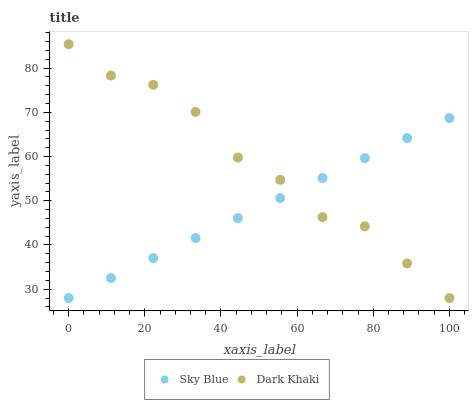Does Sky Blue have the minimum area under the curve?
Answer yes or no. Yes. Does Dark Khaki have the maximum area under the curve?
Answer yes or no. Yes. Does Sky Blue have the maximum area under the curve?
Answer yes or no. No. Is Sky Blue the smoothest?
Answer yes or no. Yes. Is Dark Khaki the roughest?
Answer yes or no. Yes. Is Sky Blue the roughest?
Answer yes or no. No. Does Dark Khaki have the lowest value?
Answer yes or no. Yes. Does Dark Khaki have the highest value?
Answer yes or no. Yes. Does Sky Blue have the highest value?
Answer yes or no. No. Does Dark Khaki intersect Sky Blue?
Answer yes or no. Yes. Is Dark Khaki less than Sky Blue?
Answer yes or no. No. Is Dark Khaki greater than Sky Blue?
Answer yes or no. No. 